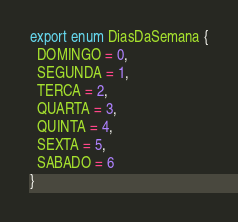<code> <loc_0><loc_0><loc_500><loc_500><_TypeScript_>export enum DiasDaSemana {
  DOMINGO = 0,
  SEGUNDA = 1,
  TERCA = 2,
  QUARTA = 3,
  QUINTA = 4,
  SEXTA = 5,
  SABADO = 6
}</code> 